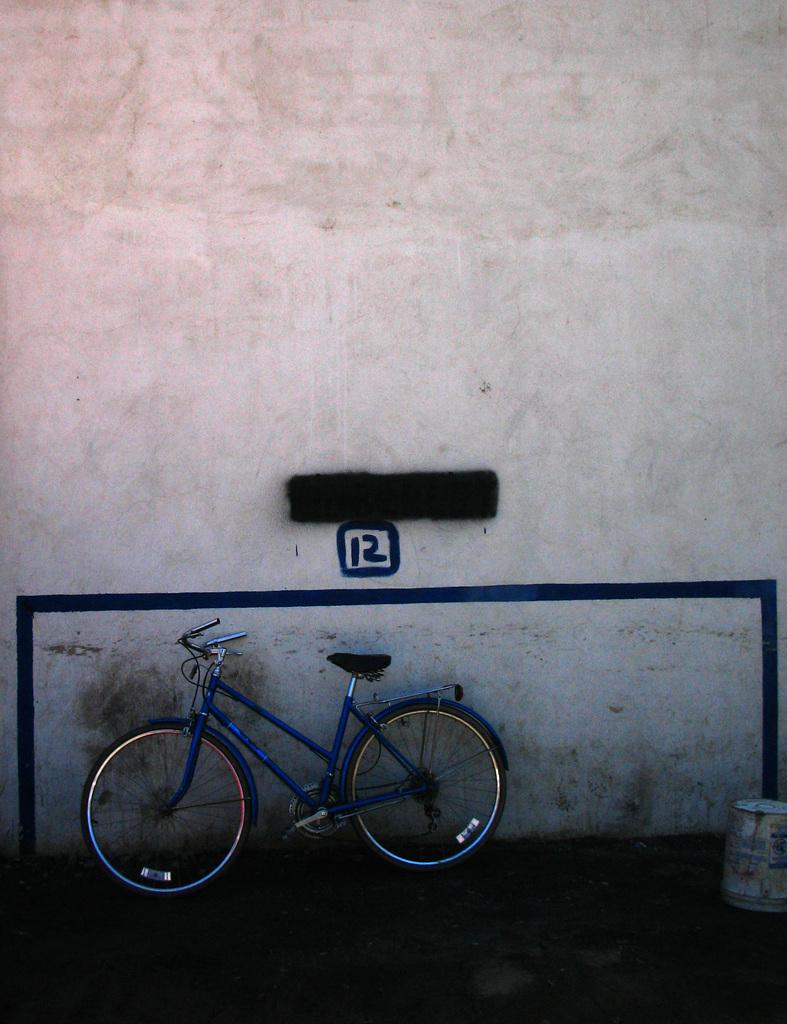What is the main subject of the image? The main subject of the image is a bicycle. What is the state of the bicycle in the image? The bicycle is parked. What can be seen in the background of the image? There is a wall in the image. Can you describe the unspecified object in the image? Unfortunately, the facts provided do not give enough information to describe the unspecified object in the image. How many jellyfish are swimming in the image? There are no jellyfish present in the image; it features a parked bicycle and a wall. What type of dolls are sitting on the bicycle in the image? There are no dolls present in the image; it only features a parked bicycle and a wall. 